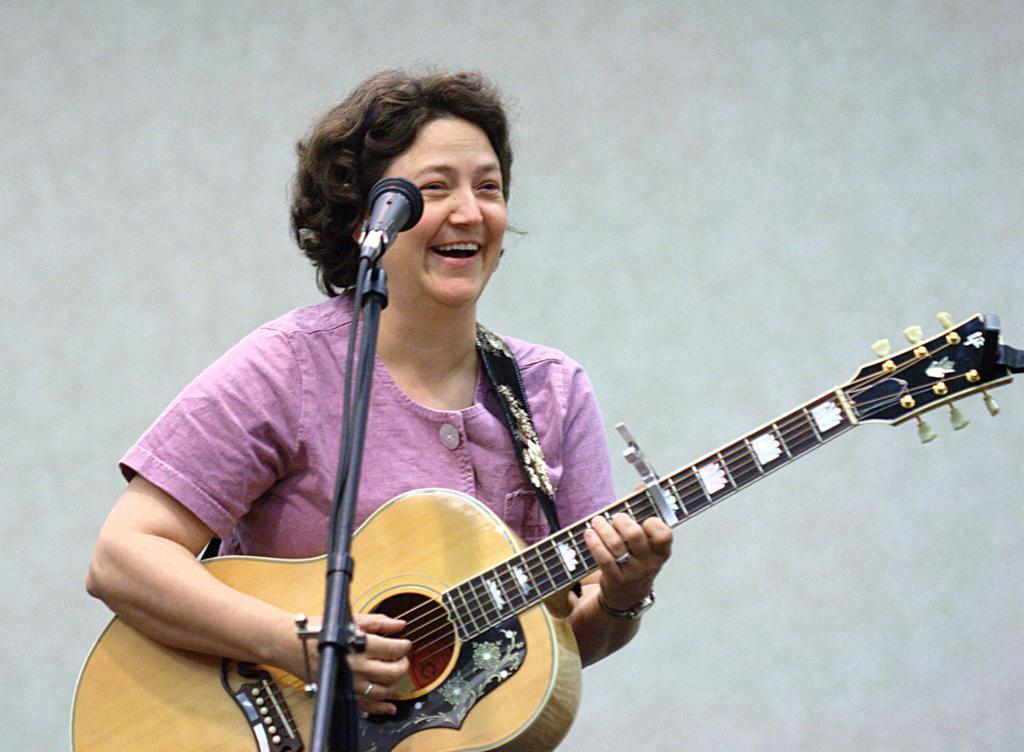Please provide a concise description of this image. In this picture, there is a woman who is wearing pink shirt is holding guitar in her hand and she is playing it. In front of her, we see a microphone and she is smiling. 